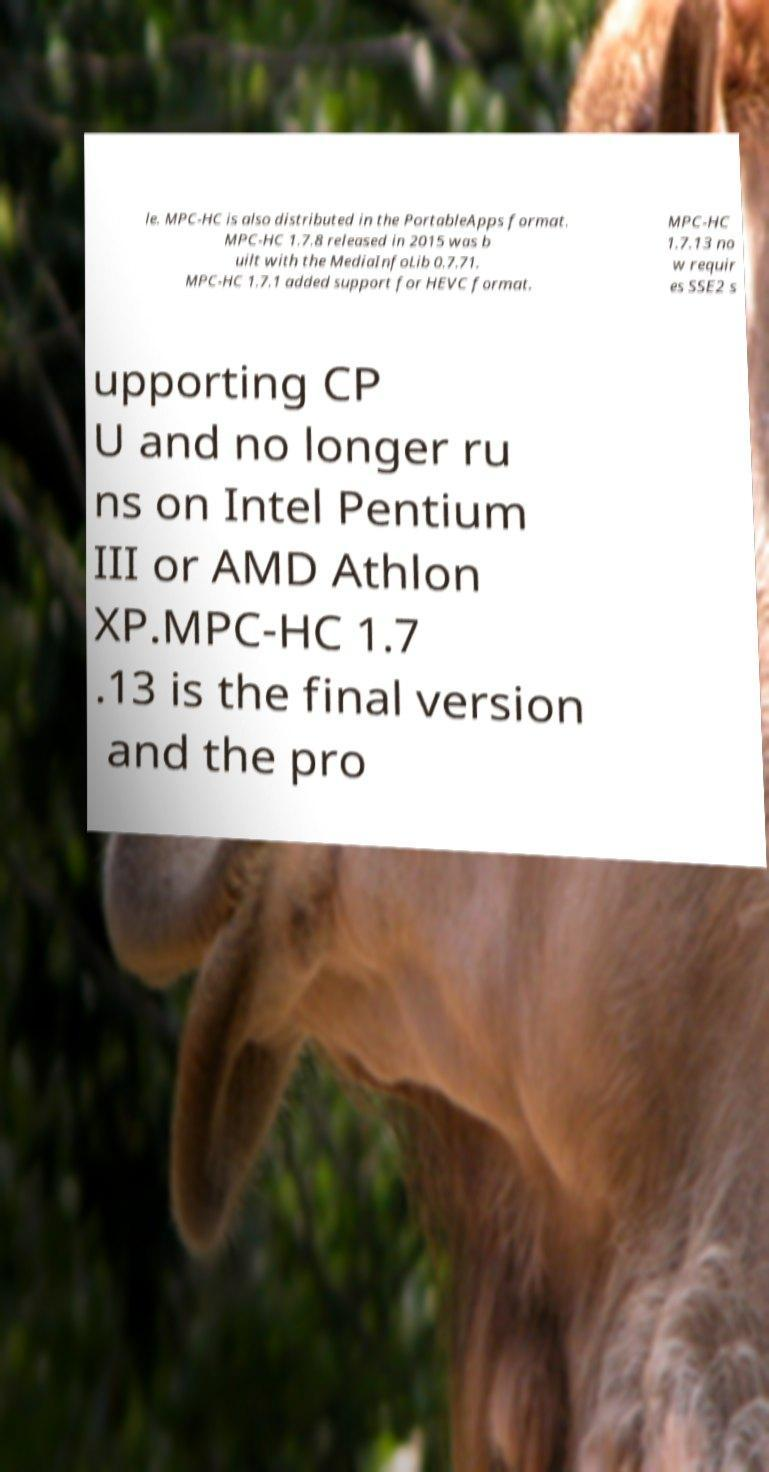Please read and relay the text visible in this image. What does it say? le. MPC-HC is also distributed in the PortableApps format. MPC-HC 1.7.8 released in 2015 was b uilt with the MediaInfoLib 0.7.71. MPC-HC 1.7.1 added support for HEVC format. MPC-HC 1.7.13 no w requir es SSE2 s upporting CP U and no longer ru ns on Intel Pentium III or AMD Athlon XP.MPC-HC 1.7 .13 is the final version and the pro 